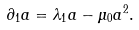<formula> <loc_0><loc_0><loc_500><loc_500>\partial _ { 1 } a = \lambda _ { 1 } a - \mu _ { 0 } a ^ { 2 } .</formula> 